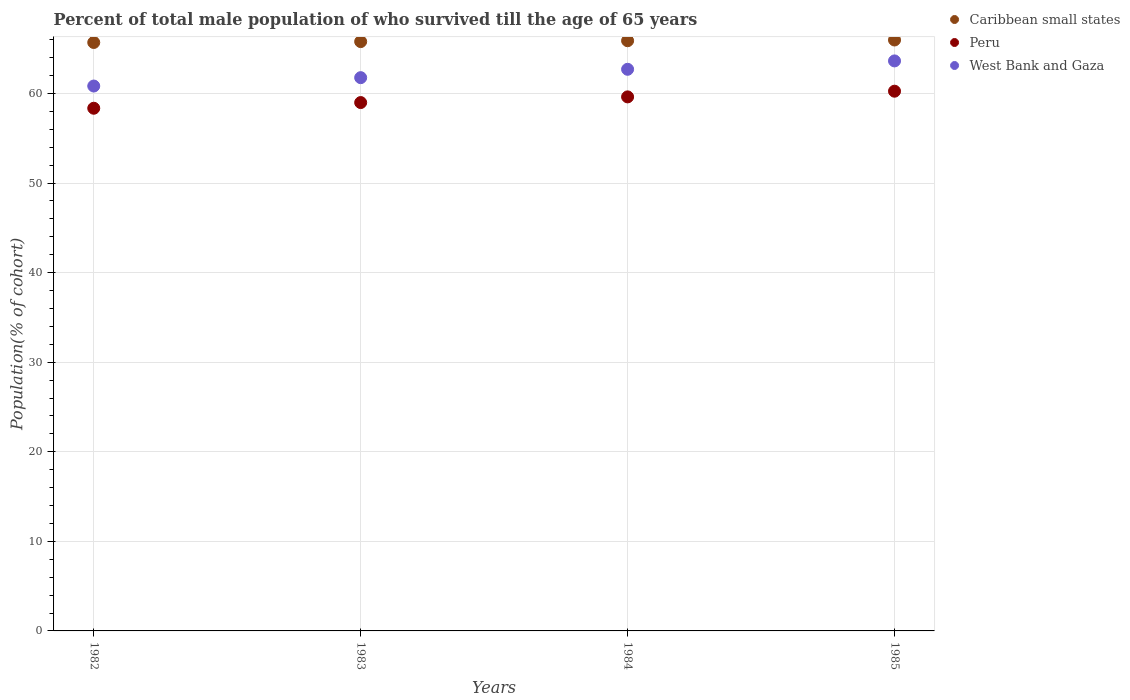How many different coloured dotlines are there?
Provide a short and direct response. 3. Is the number of dotlines equal to the number of legend labels?
Keep it short and to the point. Yes. What is the percentage of total male population who survived till the age of 65 years in Peru in 1982?
Your response must be concise. 58.35. Across all years, what is the maximum percentage of total male population who survived till the age of 65 years in Peru?
Ensure brevity in your answer.  60.26. Across all years, what is the minimum percentage of total male population who survived till the age of 65 years in Caribbean small states?
Provide a short and direct response. 65.7. In which year was the percentage of total male population who survived till the age of 65 years in West Bank and Gaza minimum?
Offer a terse response. 1982. What is the total percentage of total male population who survived till the age of 65 years in Caribbean small states in the graph?
Make the answer very short. 263.36. What is the difference between the percentage of total male population who survived till the age of 65 years in Peru in 1982 and that in 1985?
Your response must be concise. -1.9. What is the difference between the percentage of total male population who survived till the age of 65 years in Peru in 1985 and the percentage of total male population who survived till the age of 65 years in West Bank and Gaza in 1983?
Your response must be concise. -1.51. What is the average percentage of total male population who survived till the age of 65 years in Peru per year?
Your answer should be very brief. 59.31. In the year 1982, what is the difference between the percentage of total male population who survived till the age of 65 years in Peru and percentage of total male population who survived till the age of 65 years in Caribbean small states?
Ensure brevity in your answer.  -7.34. What is the ratio of the percentage of total male population who survived till the age of 65 years in Caribbean small states in 1982 to that in 1985?
Provide a succinct answer. 1. Is the difference between the percentage of total male population who survived till the age of 65 years in Peru in 1984 and 1985 greater than the difference between the percentage of total male population who survived till the age of 65 years in Caribbean small states in 1984 and 1985?
Offer a very short reply. No. What is the difference between the highest and the second highest percentage of total male population who survived till the age of 65 years in Peru?
Your answer should be compact. 0.63. What is the difference between the highest and the lowest percentage of total male population who survived till the age of 65 years in Caribbean small states?
Ensure brevity in your answer.  0.28. In how many years, is the percentage of total male population who survived till the age of 65 years in Caribbean small states greater than the average percentage of total male population who survived till the age of 65 years in Caribbean small states taken over all years?
Ensure brevity in your answer.  2. Is the sum of the percentage of total male population who survived till the age of 65 years in West Bank and Gaza in 1982 and 1984 greater than the maximum percentage of total male population who survived till the age of 65 years in Peru across all years?
Give a very brief answer. Yes. Is it the case that in every year, the sum of the percentage of total male population who survived till the age of 65 years in Peru and percentage of total male population who survived till the age of 65 years in Caribbean small states  is greater than the percentage of total male population who survived till the age of 65 years in West Bank and Gaza?
Your answer should be compact. Yes. Is the percentage of total male population who survived till the age of 65 years in Caribbean small states strictly less than the percentage of total male population who survived till the age of 65 years in Peru over the years?
Offer a very short reply. No. How many years are there in the graph?
Your answer should be very brief. 4. Does the graph contain any zero values?
Your response must be concise. No. Where does the legend appear in the graph?
Ensure brevity in your answer.  Top right. What is the title of the graph?
Offer a terse response. Percent of total male population of who survived till the age of 65 years. What is the label or title of the X-axis?
Make the answer very short. Years. What is the label or title of the Y-axis?
Give a very brief answer. Population(% of cohort). What is the Population(% of cohort) in Caribbean small states in 1982?
Ensure brevity in your answer.  65.7. What is the Population(% of cohort) of Peru in 1982?
Offer a terse response. 58.35. What is the Population(% of cohort) in West Bank and Gaza in 1982?
Your answer should be compact. 60.83. What is the Population(% of cohort) of Caribbean small states in 1983?
Give a very brief answer. 65.79. What is the Population(% of cohort) in Peru in 1983?
Your response must be concise. 58.99. What is the Population(% of cohort) of West Bank and Gaza in 1983?
Make the answer very short. 61.77. What is the Population(% of cohort) of Caribbean small states in 1984?
Ensure brevity in your answer.  65.89. What is the Population(% of cohort) of Peru in 1984?
Give a very brief answer. 59.62. What is the Population(% of cohort) of West Bank and Gaza in 1984?
Ensure brevity in your answer.  62.7. What is the Population(% of cohort) in Caribbean small states in 1985?
Ensure brevity in your answer.  65.97. What is the Population(% of cohort) of Peru in 1985?
Give a very brief answer. 60.26. What is the Population(% of cohort) in West Bank and Gaza in 1985?
Make the answer very short. 63.64. Across all years, what is the maximum Population(% of cohort) in Caribbean small states?
Your response must be concise. 65.97. Across all years, what is the maximum Population(% of cohort) in Peru?
Give a very brief answer. 60.26. Across all years, what is the maximum Population(% of cohort) of West Bank and Gaza?
Provide a succinct answer. 63.64. Across all years, what is the minimum Population(% of cohort) in Caribbean small states?
Provide a succinct answer. 65.7. Across all years, what is the minimum Population(% of cohort) of Peru?
Keep it short and to the point. 58.35. Across all years, what is the minimum Population(% of cohort) of West Bank and Gaza?
Provide a succinct answer. 60.83. What is the total Population(% of cohort) of Caribbean small states in the graph?
Make the answer very short. 263.36. What is the total Population(% of cohort) of Peru in the graph?
Keep it short and to the point. 237.22. What is the total Population(% of cohort) in West Bank and Gaza in the graph?
Your response must be concise. 248.94. What is the difference between the Population(% of cohort) in Caribbean small states in 1982 and that in 1983?
Give a very brief answer. -0.1. What is the difference between the Population(% of cohort) in Peru in 1982 and that in 1983?
Keep it short and to the point. -0.63. What is the difference between the Population(% of cohort) of West Bank and Gaza in 1982 and that in 1983?
Your response must be concise. -0.93. What is the difference between the Population(% of cohort) in Caribbean small states in 1982 and that in 1984?
Your answer should be very brief. -0.2. What is the difference between the Population(% of cohort) of Peru in 1982 and that in 1984?
Provide a succinct answer. -1.27. What is the difference between the Population(% of cohort) in West Bank and Gaza in 1982 and that in 1984?
Offer a terse response. -1.87. What is the difference between the Population(% of cohort) of Caribbean small states in 1982 and that in 1985?
Provide a short and direct response. -0.28. What is the difference between the Population(% of cohort) of Peru in 1982 and that in 1985?
Your answer should be compact. -1.9. What is the difference between the Population(% of cohort) of West Bank and Gaza in 1982 and that in 1985?
Ensure brevity in your answer.  -2.8. What is the difference between the Population(% of cohort) in Caribbean small states in 1983 and that in 1984?
Your answer should be compact. -0.1. What is the difference between the Population(% of cohort) in Peru in 1983 and that in 1984?
Your answer should be very brief. -0.63. What is the difference between the Population(% of cohort) in West Bank and Gaza in 1983 and that in 1984?
Make the answer very short. -0.93. What is the difference between the Population(% of cohort) of Caribbean small states in 1983 and that in 1985?
Your response must be concise. -0.18. What is the difference between the Population(% of cohort) of Peru in 1983 and that in 1985?
Your answer should be compact. -1.27. What is the difference between the Population(% of cohort) of West Bank and Gaza in 1983 and that in 1985?
Your response must be concise. -1.87. What is the difference between the Population(% of cohort) of Caribbean small states in 1984 and that in 1985?
Your answer should be very brief. -0.08. What is the difference between the Population(% of cohort) of Peru in 1984 and that in 1985?
Offer a terse response. -0.63. What is the difference between the Population(% of cohort) of West Bank and Gaza in 1984 and that in 1985?
Offer a very short reply. -0.93. What is the difference between the Population(% of cohort) of Caribbean small states in 1982 and the Population(% of cohort) of Peru in 1983?
Your answer should be very brief. 6.71. What is the difference between the Population(% of cohort) in Caribbean small states in 1982 and the Population(% of cohort) in West Bank and Gaza in 1983?
Give a very brief answer. 3.93. What is the difference between the Population(% of cohort) in Peru in 1982 and the Population(% of cohort) in West Bank and Gaza in 1983?
Make the answer very short. -3.41. What is the difference between the Population(% of cohort) in Caribbean small states in 1982 and the Population(% of cohort) in Peru in 1984?
Offer a very short reply. 6.07. What is the difference between the Population(% of cohort) of Caribbean small states in 1982 and the Population(% of cohort) of West Bank and Gaza in 1984?
Offer a terse response. 2.99. What is the difference between the Population(% of cohort) of Peru in 1982 and the Population(% of cohort) of West Bank and Gaza in 1984?
Make the answer very short. -4.35. What is the difference between the Population(% of cohort) in Caribbean small states in 1982 and the Population(% of cohort) in Peru in 1985?
Provide a short and direct response. 5.44. What is the difference between the Population(% of cohort) in Caribbean small states in 1982 and the Population(% of cohort) in West Bank and Gaza in 1985?
Provide a short and direct response. 2.06. What is the difference between the Population(% of cohort) of Peru in 1982 and the Population(% of cohort) of West Bank and Gaza in 1985?
Make the answer very short. -5.28. What is the difference between the Population(% of cohort) in Caribbean small states in 1983 and the Population(% of cohort) in Peru in 1984?
Your answer should be very brief. 6.17. What is the difference between the Population(% of cohort) of Caribbean small states in 1983 and the Population(% of cohort) of West Bank and Gaza in 1984?
Provide a short and direct response. 3.09. What is the difference between the Population(% of cohort) in Peru in 1983 and the Population(% of cohort) in West Bank and Gaza in 1984?
Provide a short and direct response. -3.71. What is the difference between the Population(% of cohort) in Caribbean small states in 1983 and the Population(% of cohort) in Peru in 1985?
Make the answer very short. 5.54. What is the difference between the Population(% of cohort) in Caribbean small states in 1983 and the Population(% of cohort) in West Bank and Gaza in 1985?
Your answer should be very brief. 2.16. What is the difference between the Population(% of cohort) in Peru in 1983 and the Population(% of cohort) in West Bank and Gaza in 1985?
Your answer should be very brief. -4.65. What is the difference between the Population(% of cohort) of Caribbean small states in 1984 and the Population(% of cohort) of Peru in 1985?
Offer a very short reply. 5.63. What is the difference between the Population(% of cohort) of Caribbean small states in 1984 and the Population(% of cohort) of West Bank and Gaza in 1985?
Provide a short and direct response. 2.25. What is the difference between the Population(% of cohort) of Peru in 1984 and the Population(% of cohort) of West Bank and Gaza in 1985?
Keep it short and to the point. -4.02. What is the average Population(% of cohort) in Caribbean small states per year?
Make the answer very short. 65.84. What is the average Population(% of cohort) in Peru per year?
Give a very brief answer. 59.31. What is the average Population(% of cohort) in West Bank and Gaza per year?
Offer a terse response. 62.24. In the year 1982, what is the difference between the Population(% of cohort) in Caribbean small states and Population(% of cohort) in Peru?
Provide a succinct answer. 7.34. In the year 1982, what is the difference between the Population(% of cohort) of Caribbean small states and Population(% of cohort) of West Bank and Gaza?
Provide a short and direct response. 4.86. In the year 1982, what is the difference between the Population(% of cohort) in Peru and Population(% of cohort) in West Bank and Gaza?
Offer a very short reply. -2.48. In the year 1983, what is the difference between the Population(% of cohort) in Caribbean small states and Population(% of cohort) in Peru?
Your response must be concise. 6.81. In the year 1983, what is the difference between the Population(% of cohort) of Caribbean small states and Population(% of cohort) of West Bank and Gaza?
Ensure brevity in your answer.  4.03. In the year 1983, what is the difference between the Population(% of cohort) of Peru and Population(% of cohort) of West Bank and Gaza?
Offer a very short reply. -2.78. In the year 1984, what is the difference between the Population(% of cohort) of Caribbean small states and Population(% of cohort) of Peru?
Provide a succinct answer. 6.27. In the year 1984, what is the difference between the Population(% of cohort) of Caribbean small states and Population(% of cohort) of West Bank and Gaza?
Keep it short and to the point. 3.19. In the year 1984, what is the difference between the Population(% of cohort) of Peru and Population(% of cohort) of West Bank and Gaza?
Your answer should be compact. -3.08. In the year 1985, what is the difference between the Population(% of cohort) in Caribbean small states and Population(% of cohort) in Peru?
Make the answer very short. 5.72. In the year 1985, what is the difference between the Population(% of cohort) in Caribbean small states and Population(% of cohort) in West Bank and Gaza?
Make the answer very short. 2.34. In the year 1985, what is the difference between the Population(% of cohort) in Peru and Population(% of cohort) in West Bank and Gaza?
Provide a succinct answer. -3.38. What is the ratio of the Population(% of cohort) in Peru in 1982 to that in 1983?
Your response must be concise. 0.99. What is the ratio of the Population(% of cohort) in West Bank and Gaza in 1982 to that in 1983?
Keep it short and to the point. 0.98. What is the ratio of the Population(% of cohort) of Peru in 1982 to that in 1984?
Give a very brief answer. 0.98. What is the ratio of the Population(% of cohort) of West Bank and Gaza in 1982 to that in 1984?
Keep it short and to the point. 0.97. What is the ratio of the Population(% of cohort) in Caribbean small states in 1982 to that in 1985?
Your answer should be very brief. 1. What is the ratio of the Population(% of cohort) in Peru in 1982 to that in 1985?
Offer a very short reply. 0.97. What is the ratio of the Population(% of cohort) in West Bank and Gaza in 1982 to that in 1985?
Ensure brevity in your answer.  0.96. What is the ratio of the Population(% of cohort) of Caribbean small states in 1983 to that in 1984?
Provide a short and direct response. 1. What is the ratio of the Population(% of cohort) of West Bank and Gaza in 1983 to that in 1984?
Your answer should be very brief. 0.99. What is the ratio of the Population(% of cohort) of Caribbean small states in 1983 to that in 1985?
Make the answer very short. 1. What is the ratio of the Population(% of cohort) in Peru in 1983 to that in 1985?
Provide a short and direct response. 0.98. What is the ratio of the Population(% of cohort) in West Bank and Gaza in 1983 to that in 1985?
Give a very brief answer. 0.97. What is the ratio of the Population(% of cohort) of Caribbean small states in 1984 to that in 1985?
Make the answer very short. 1. What is the ratio of the Population(% of cohort) of Peru in 1984 to that in 1985?
Keep it short and to the point. 0.99. What is the difference between the highest and the second highest Population(% of cohort) in Caribbean small states?
Offer a very short reply. 0.08. What is the difference between the highest and the second highest Population(% of cohort) of Peru?
Ensure brevity in your answer.  0.63. What is the difference between the highest and the second highest Population(% of cohort) in West Bank and Gaza?
Provide a short and direct response. 0.93. What is the difference between the highest and the lowest Population(% of cohort) of Caribbean small states?
Keep it short and to the point. 0.28. What is the difference between the highest and the lowest Population(% of cohort) in Peru?
Give a very brief answer. 1.9. What is the difference between the highest and the lowest Population(% of cohort) of West Bank and Gaza?
Give a very brief answer. 2.8. 